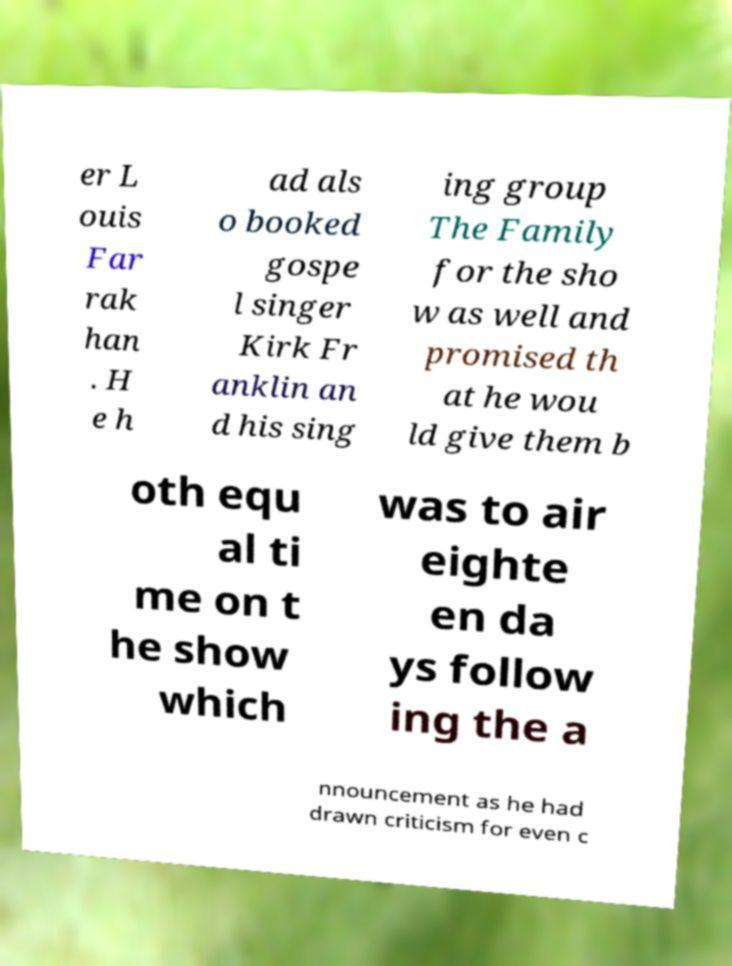Could you extract and type out the text from this image? er L ouis Far rak han . H e h ad als o booked gospe l singer Kirk Fr anklin an d his sing ing group The Family for the sho w as well and promised th at he wou ld give them b oth equ al ti me on t he show which was to air eighte en da ys follow ing the a nnouncement as he had drawn criticism for even c 